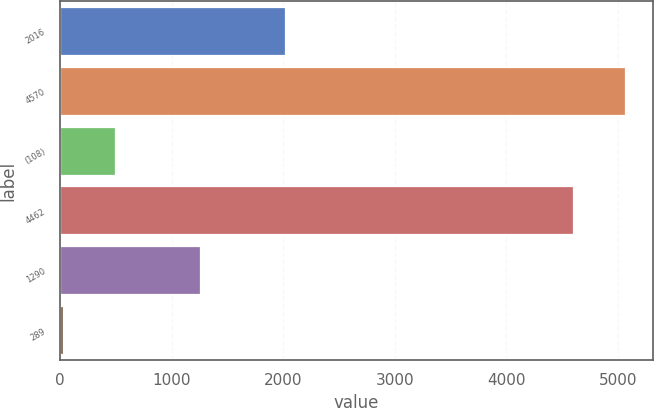Convert chart to OTSL. <chart><loc_0><loc_0><loc_500><loc_500><bar_chart><fcel>2016<fcel>4570<fcel>(108)<fcel>4462<fcel>1290<fcel>289<nl><fcel>2015<fcel>5058.68<fcel>490.88<fcel>4595<fcel>1250<fcel>27.2<nl></chart> 